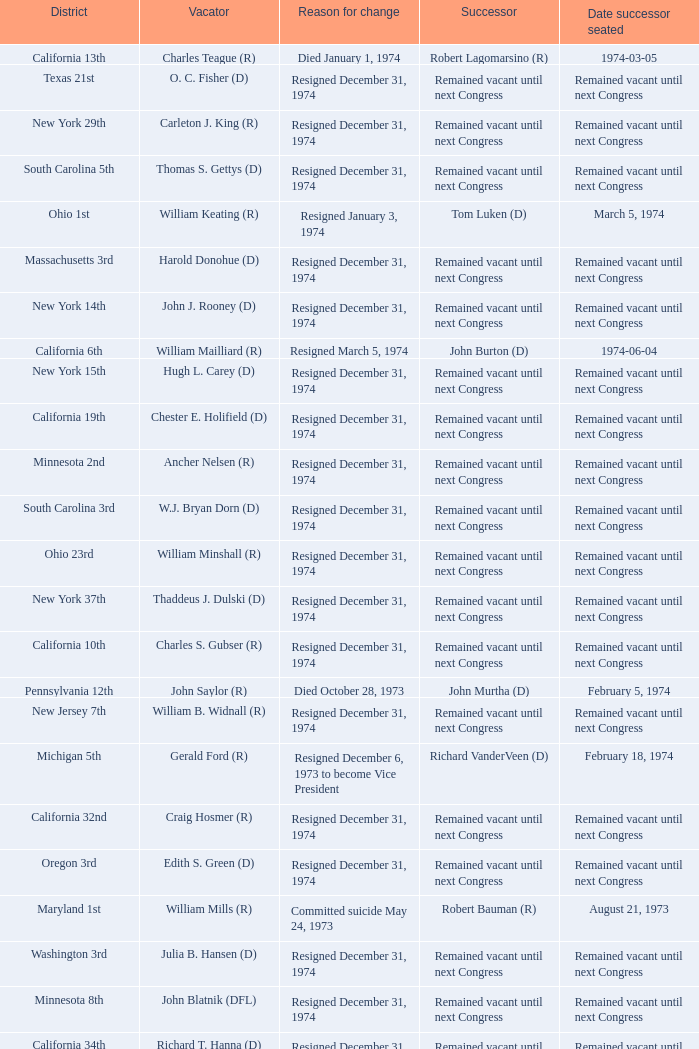When was the date successor seated when the vacator was charles e. chamberlain (r)? Remained vacant until next Congress. 